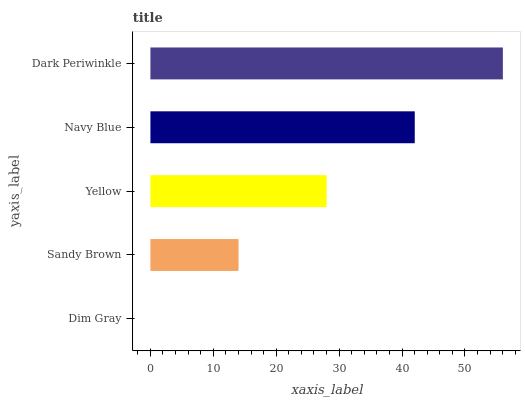Is Dim Gray the minimum?
Answer yes or no. Yes. Is Dark Periwinkle the maximum?
Answer yes or no. Yes. Is Sandy Brown the minimum?
Answer yes or no. No. Is Sandy Brown the maximum?
Answer yes or no. No. Is Sandy Brown greater than Dim Gray?
Answer yes or no. Yes. Is Dim Gray less than Sandy Brown?
Answer yes or no. Yes. Is Dim Gray greater than Sandy Brown?
Answer yes or no. No. Is Sandy Brown less than Dim Gray?
Answer yes or no. No. Is Yellow the high median?
Answer yes or no. Yes. Is Yellow the low median?
Answer yes or no. Yes. Is Dim Gray the high median?
Answer yes or no. No. Is Dark Periwinkle the low median?
Answer yes or no. No. 